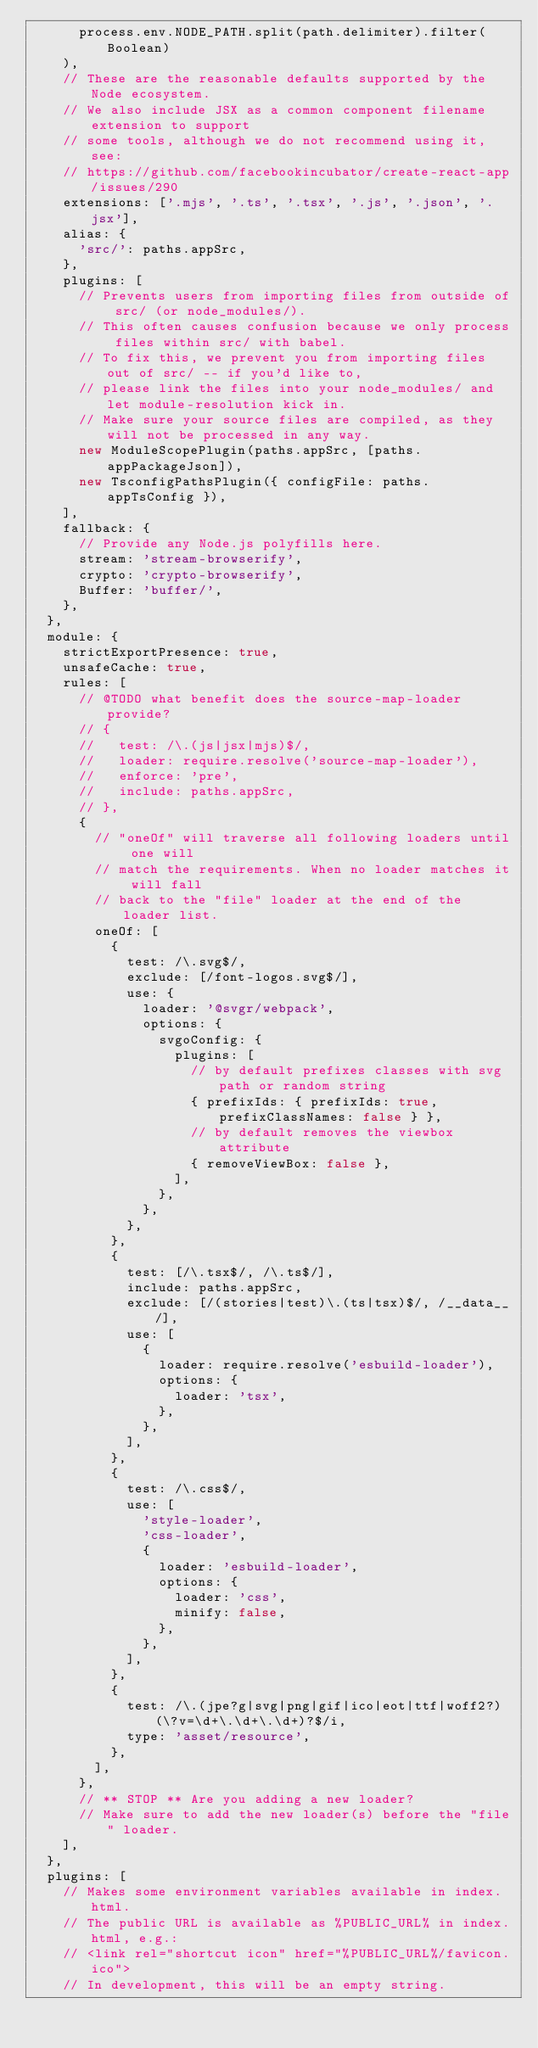Convert code to text. <code><loc_0><loc_0><loc_500><loc_500><_JavaScript_>      process.env.NODE_PATH.split(path.delimiter).filter(Boolean)
    ),
    // These are the reasonable defaults supported by the Node ecosystem.
    // We also include JSX as a common component filename extension to support
    // some tools, although we do not recommend using it, see:
    // https://github.com/facebookincubator/create-react-app/issues/290
    extensions: ['.mjs', '.ts', '.tsx', '.js', '.json', '.jsx'],
    alias: {
      'src/': paths.appSrc,
    },
    plugins: [
      // Prevents users from importing files from outside of src/ (or node_modules/).
      // This often causes confusion because we only process files within src/ with babel.
      // To fix this, we prevent you from importing files out of src/ -- if you'd like to,
      // please link the files into your node_modules/ and let module-resolution kick in.
      // Make sure your source files are compiled, as they will not be processed in any way.
      new ModuleScopePlugin(paths.appSrc, [paths.appPackageJson]),
      new TsconfigPathsPlugin({ configFile: paths.appTsConfig }),
    ],
    fallback: {
      // Provide any Node.js polyfills here.
      stream: 'stream-browserify',
      crypto: 'crypto-browserify',
      Buffer: 'buffer/',
    },
  },
  module: {
    strictExportPresence: true,
    unsafeCache: true,
    rules: [
      // @TODO what benefit does the source-map-loader provide?
      // {
      //   test: /\.(js|jsx|mjs)$/,
      //   loader: require.resolve('source-map-loader'),
      //   enforce: 'pre',
      //   include: paths.appSrc,
      // },
      {
        // "oneOf" will traverse all following loaders until one will
        // match the requirements. When no loader matches it will fall
        // back to the "file" loader at the end of the loader list.
        oneOf: [
          {
            test: /\.svg$/,
            exclude: [/font-logos.svg$/],
            use: {
              loader: '@svgr/webpack',
              options: {
                svgoConfig: {
                  plugins: [
                    // by default prefixes classes with svg path or random string
                    { prefixIds: { prefixIds: true, prefixClassNames: false } },
                    // by default removes the viewbox attribute
                    { removeViewBox: false },
                  ],
                },
              },
            },
          },
          {
            test: [/\.tsx$/, /\.ts$/],
            include: paths.appSrc,
            exclude: [/(stories|test)\.(ts|tsx)$/, /__data__/],
            use: [
              {
                loader: require.resolve('esbuild-loader'),
                options: {
                  loader: 'tsx',
                },
              },
            ],
          },
          {
            test: /\.css$/,
            use: [
              'style-loader',
              'css-loader',
              {
                loader: 'esbuild-loader',
                options: {
                  loader: 'css',
                  minify: false,
                },
              },
            ],
          },
          {
            test: /\.(jpe?g|svg|png|gif|ico|eot|ttf|woff2?)(\?v=\d+\.\d+\.\d+)?$/i,
            type: 'asset/resource',
          },
        ],
      },
      // ** STOP ** Are you adding a new loader?
      // Make sure to add the new loader(s) before the "file" loader.
    ],
  },
  plugins: [
    // Makes some environment variables available in index.html.
    // The public URL is available as %PUBLIC_URL% in index.html, e.g.:
    // <link rel="shortcut icon" href="%PUBLIC_URL%/favicon.ico">
    // In development, this will be an empty string.</code> 